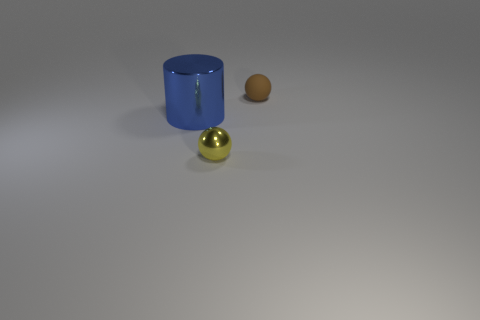There is a sphere on the right side of the object in front of the large blue cylinder; what is its color?
Make the answer very short. Brown. How many other objects are the same shape as the blue object?
Provide a succinct answer. 0. Is there a large blue object made of the same material as the tiny yellow object?
Ensure brevity in your answer.  Yes. There is a object that is the same size as the yellow metal sphere; what is its material?
Make the answer very short. Rubber. There is a tiny ball that is left of the tiny thing behind the small thing that is left of the small brown matte thing; what color is it?
Provide a succinct answer. Yellow. There is a small object that is in front of the big blue metallic cylinder; is its shape the same as the blue metallic object behind the tiny metallic thing?
Your response must be concise. No. How many shiny things are there?
Give a very brief answer. 2. What color is the other sphere that is the same size as the yellow ball?
Your answer should be very brief. Brown. Are the yellow sphere that is to the right of the large shiny thing and the sphere behind the tiny yellow metallic ball made of the same material?
Provide a short and direct response. No. What size is the object to the right of the small object that is in front of the blue thing?
Provide a short and direct response. Small. 